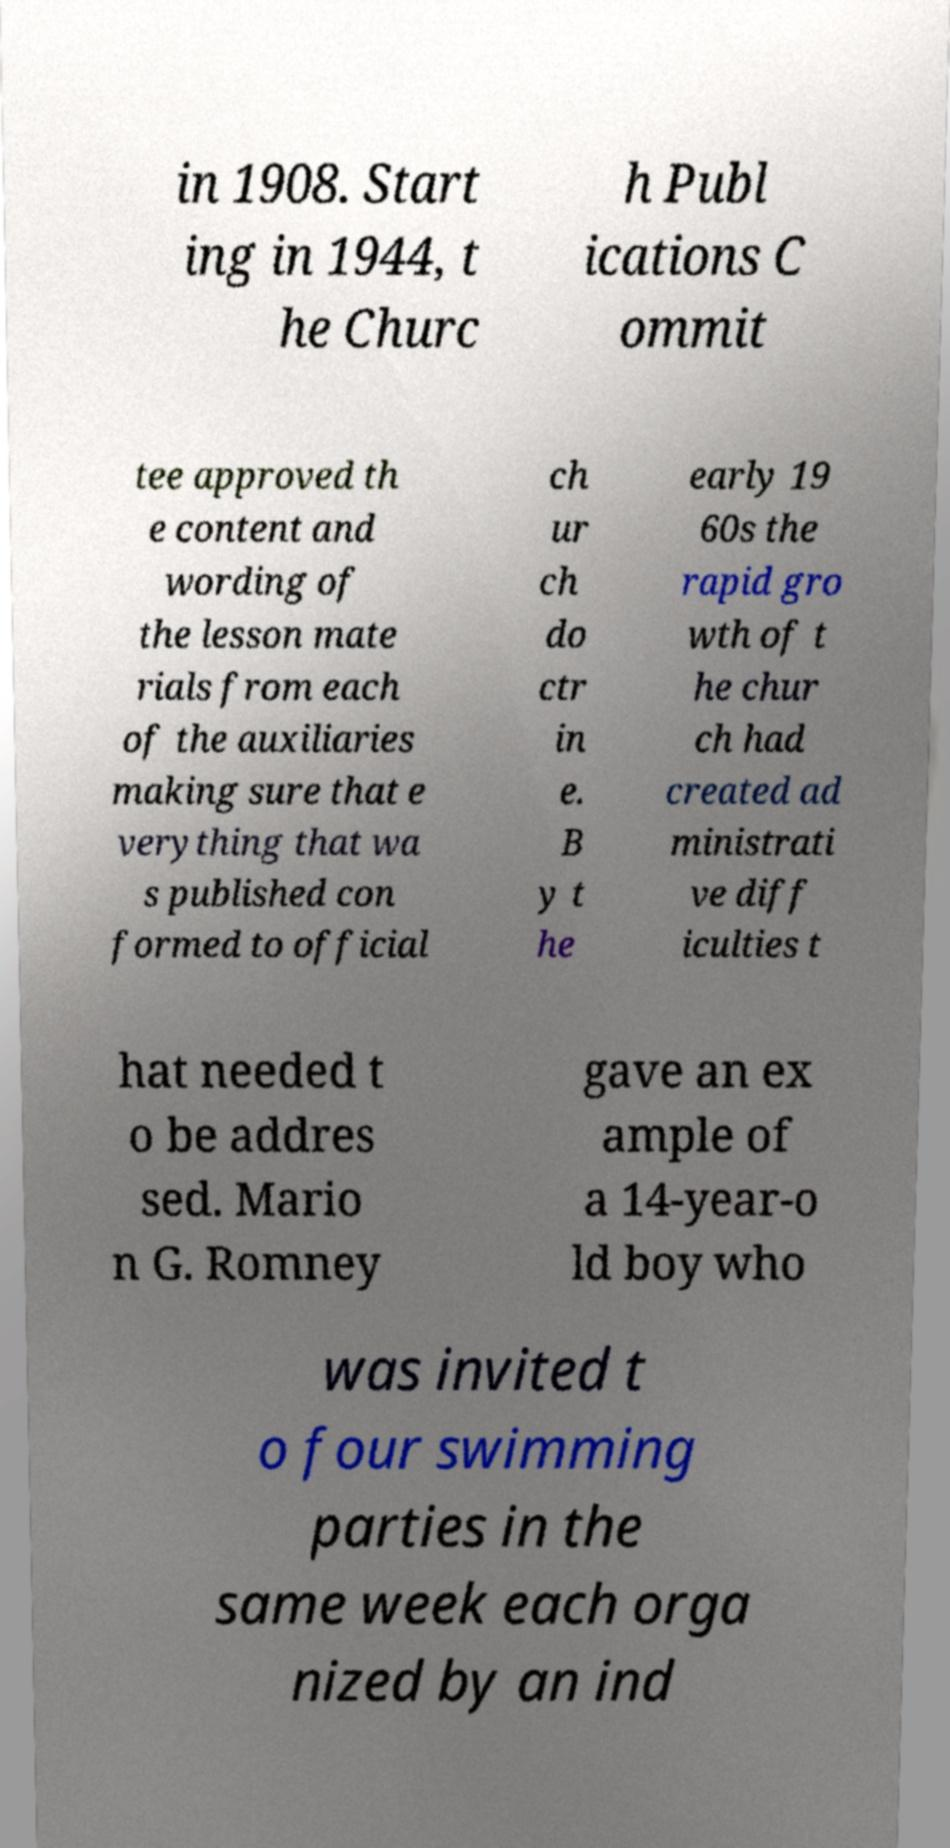There's text embedded in this image that I need extracted. Can you transcribe it verbatim? in 1908. Start ing in 1944, t he Churc h Publ ications C ommit tee approved th e content and wording of the lesson mate rials from each of the auxiliaries making sure that e verything that wa s published con formed to official ch ur ch do ctr in e. B y t he early 19 60s the rapid gro wth of t he chur ch had created ad ministrati ve diff iculties t hat needed t o be addres sed. Mario n G. Romney gave an ex ample of a 14-year-o ld boy who was invited t o four swimming parties in the same week each orga nized by an ind 